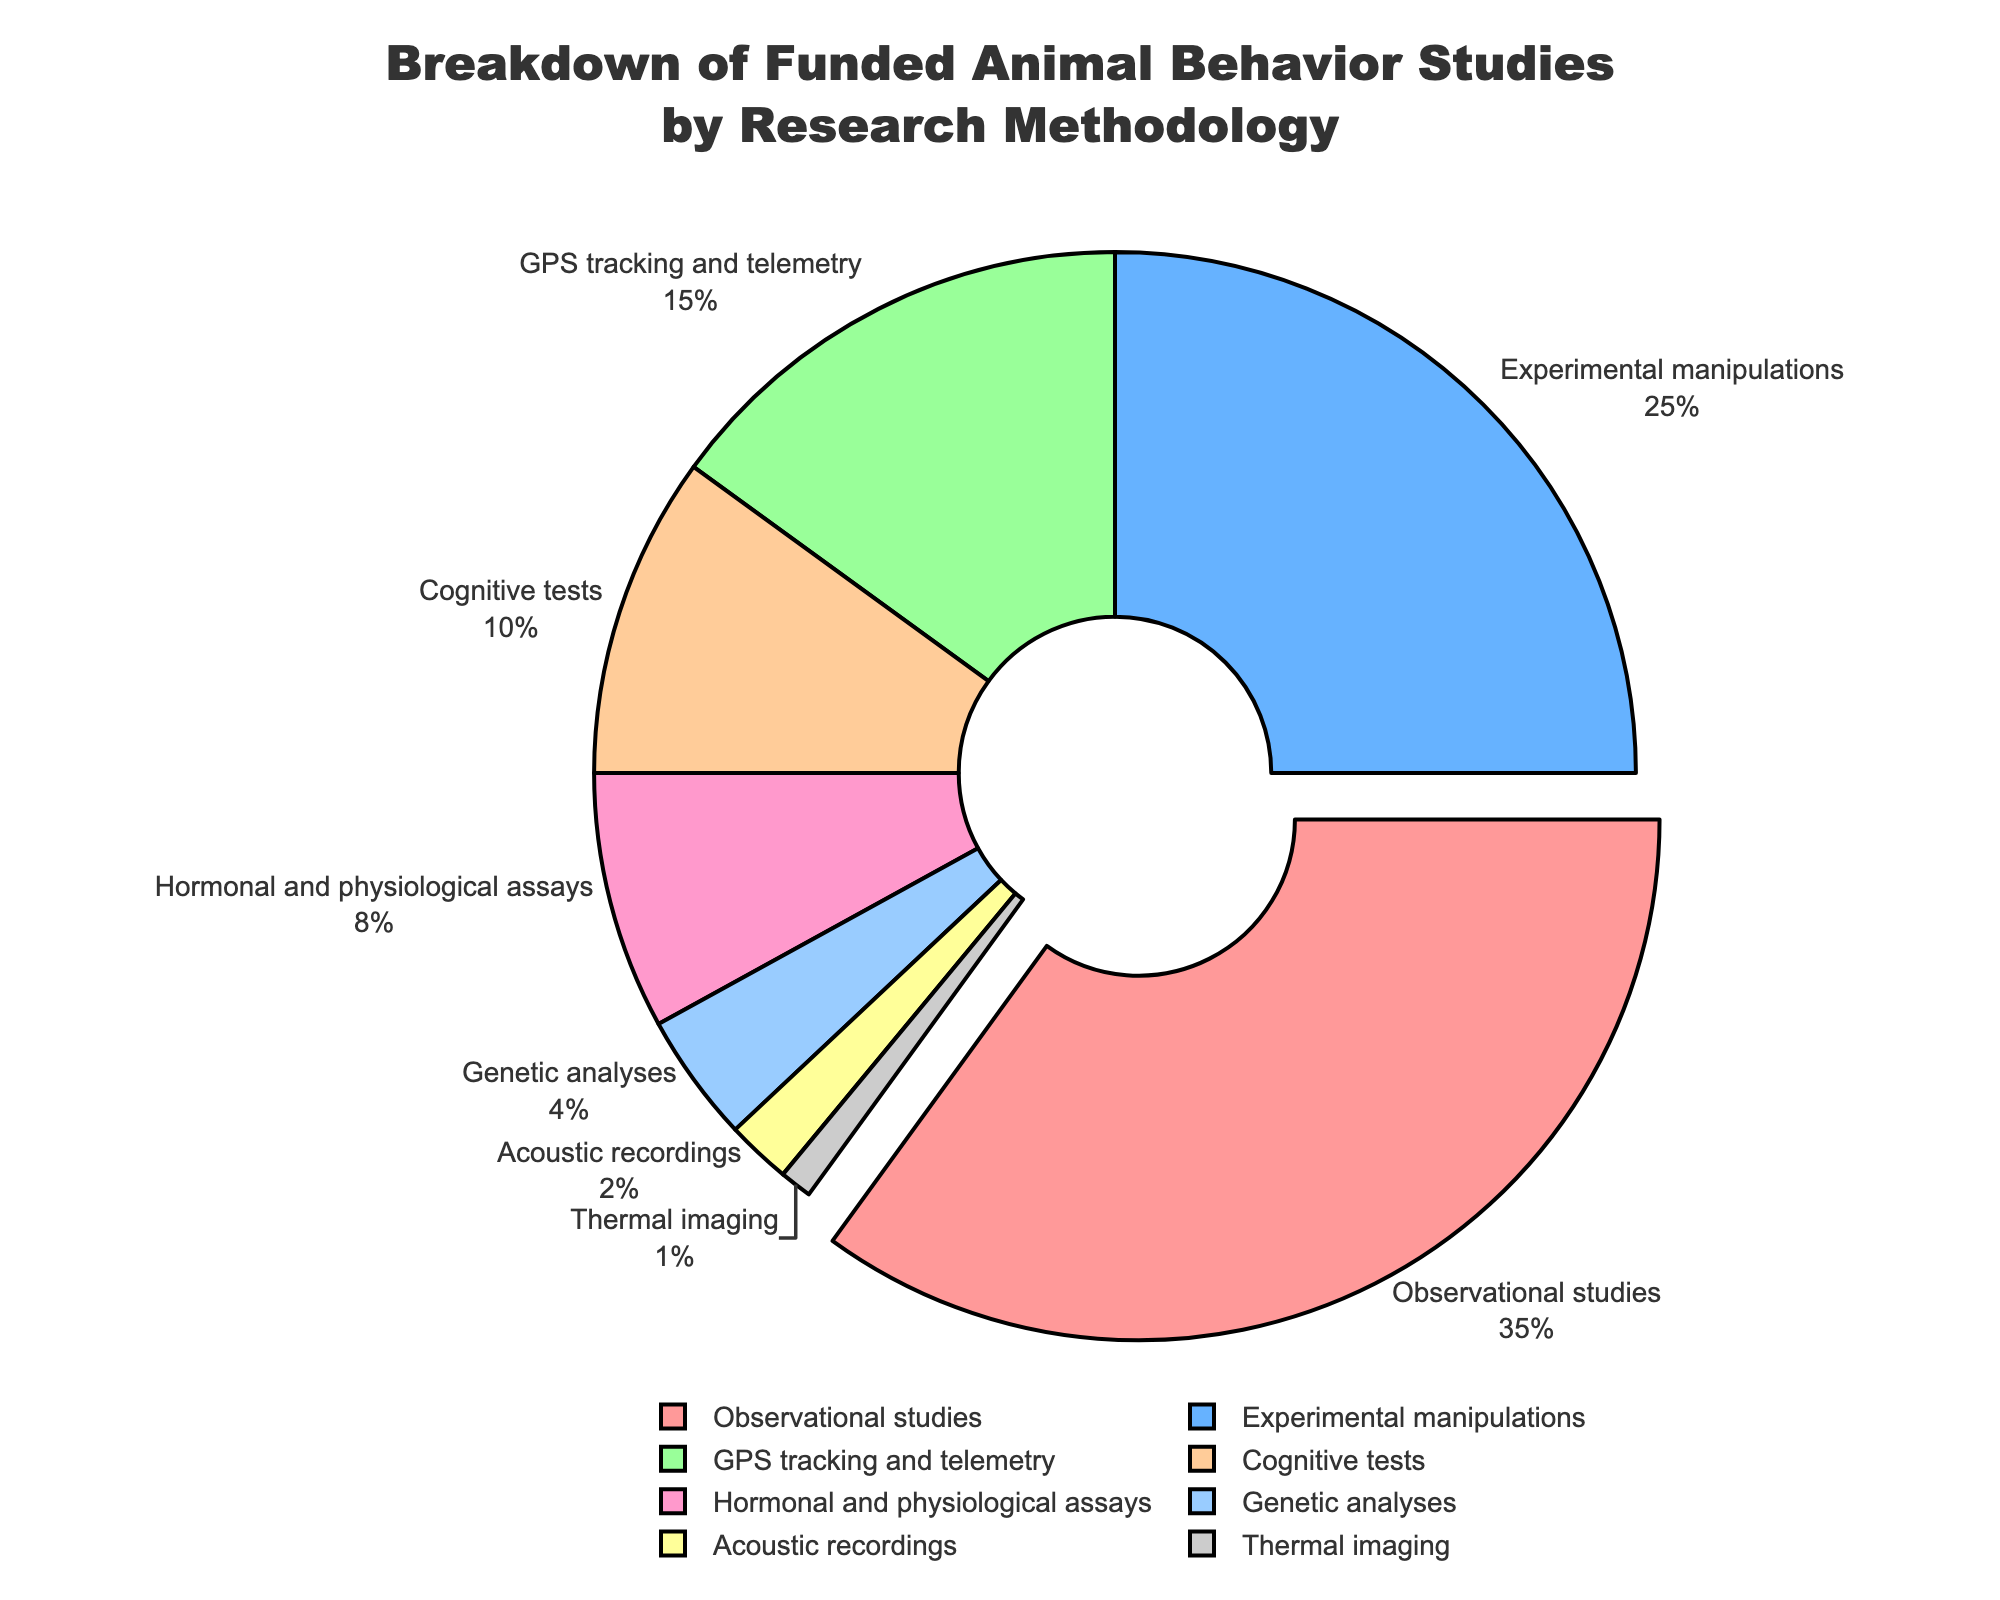Which research methodology has the highest funding percentage? The methodology with the largest portion of the pie chart is "Observational studies" which occupies the most significant slice.
Answer: Observational studies What percentage of the total funding is allocated to Experimental manipulations and GPS tracking and telemetry combined? Summing the percentages for "Experimental manipulations" (25%) and "GPS tracking and telemetry" (15%) gives a total of 40%.
Answer: 40% Which research methodology category has a smaller funding percentage compared to Genetic analyses? The only category with a smaller percentage than "Genetic analyses" (4%) is "Acoustic recordings" (2%) and "Thermal imaging" (1%).
Answer: Acoustic recordings and Thermal imaging How much more funding (in percentage) does Observational studies receive compared to Cognitive tests? Subtracting the percentage of "Cognitive tests" (10%) from "Observational studies" (35%) gives a difference of 25%.
Answer: 25% Is the combined funding for Hormonal and physiological assays and Genetic analyses greater than the funding for Experimental manipulations? Adding the percentages for "Hormonal and physiological assays" (8%) and "Genetic analyses" (4%) results in 12%. This is less than the 25% allocated to "Experimental manipulations".
Answer: No Which visual attribute distinguishes Observational studies on the pie chart? "Observational studies" slice is visually distinguished because it is pulled out slightly from the pie chart compared to the other slices.
Answer: Pulled out How many research methodologies receive less than 10% of the total funding each? Counting the slices with percentages less than 10%: "Hormonal and physiological assays" (8%), "Genetic analyses" (4%), "Acoustic recordings" (2%), and "Thermal imaging" (1%) results in 4 methodologies.
Answer: 4 What is the smallest funding percentage allocated among all research methodologies, and which methodology does it correspond to? The smallest slice on the pie chart represents "Thermal imaging" with 1% of the total funding.
Answer: 1%, Thermal imaging Which research methodologies combined contribute to more than 50% of the total funding? Summing the top two slices: "Observational studies" (35%) and "Experimental manipulations" (25%), the total is 60%, which is more than 50%.
Answer: Observational studies and Experimental manipulations 